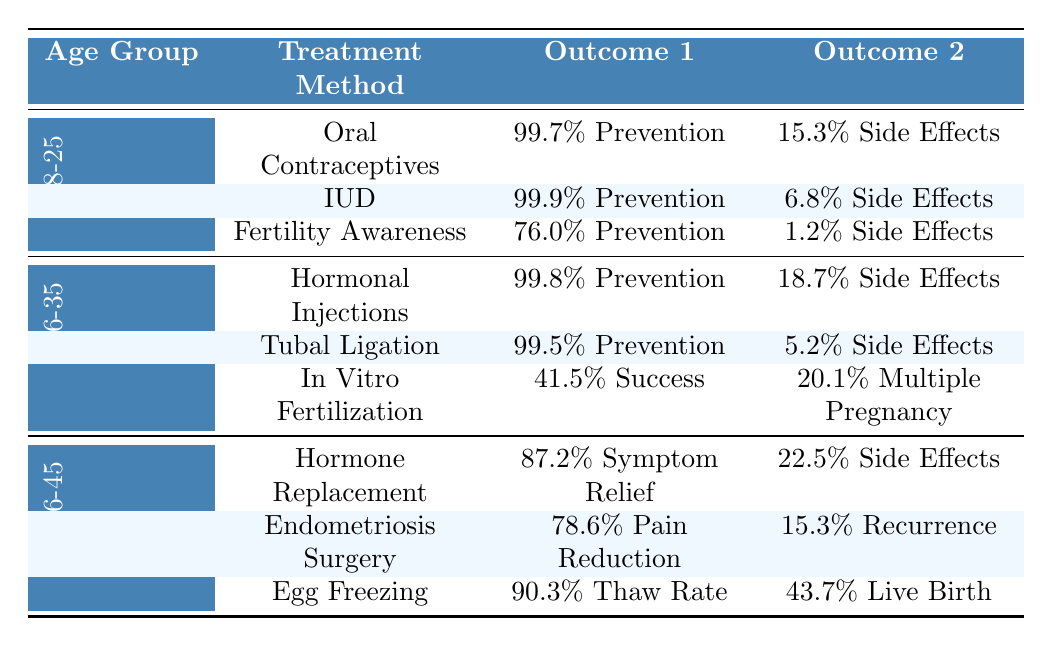What is the pregnancy prevention rate for IUD in the 18-25 age group? From the table, the prevention rate for IUD in the 18-25 age group is shown as 99.9%.
Answer: 99.9% Which treatment method has the lowest side effects incidence in the 18-25 age group? The side effects incidence for each method in the 18-25 age group is: Oral Contraceptives 15.3%, IUD 6.8%, Fertility Awareness 1.2%. Fertility Awareness has the lowest incidence at 1.2%.
Answer: Fertility Awareness What is the success rate of In Vitro Fertilization for the 26-35 age group? The table indicates that the success rate for In Vitro Fertilization in the 26-35 age group is 41.5%.
Answer: 41.5% Which age group has the highest patient satisfaction for Tubal Ligation? Tubal Ligation is categorized under the 26-35 age group, which shows a patient satisfaction rating of 9.3%. There are no other age groups for this treatment method.
Answer: 9.3 Are side effects incidence rates higher for Hormonal Injections compared to Oral Contraceptives in their respective age groups? Hormonal Injections have a side effects incidence of 18.7% in the 26-35 age group and Oral Contraceptives have 15.3% in the 18-25 age group. Since 18.7% > 15.3%, the statement is true.
Answer: Yes What is the average patient satisfaction for the 36-45 age group based on the treatments listed? The patient satisfaction ratings for the treatments in this age group are: Hormone Replacement Therapy 8.4, Endometriosis Surgery 8.9, Egg Freezing 8.6. Summing these gives 8.4 + 8.9 + 8.6 = 25.9. Dividing by 3, the average is 25.9/3 = 8.63.
Answer: 8.63 In the 36-45 age group, is the successful thaw rate for Egg Freezing higher than the pain reduction rate for Endometriosis Surgery? The successful thaw rate for Egg Freezing is 90.3%, while the pain reduction rate for Endometriosis Surgery is 78.6%. Since 90.3% > 78.6%, the statement is true.
Answer: Yes Which treatment method has the highest pregnancy prevention rate among all the methods listed? The highest pregnancy prevention rate from the table is 99.9% for the IUD in the 18-25 age group.
Answer: IUD at 99.9% What is the difference between the side effects incidence of Hormone Replacement Therapy and Egg Freezing in the 36-45 age group? Hormone Replacement Therapy has a side effects incidence of 22.5%, while Egg Freezing has none listed, assumed to be 0%. The difference is calculated as 22.5% - 0% = 22.5%.
Answer: 22.5% 